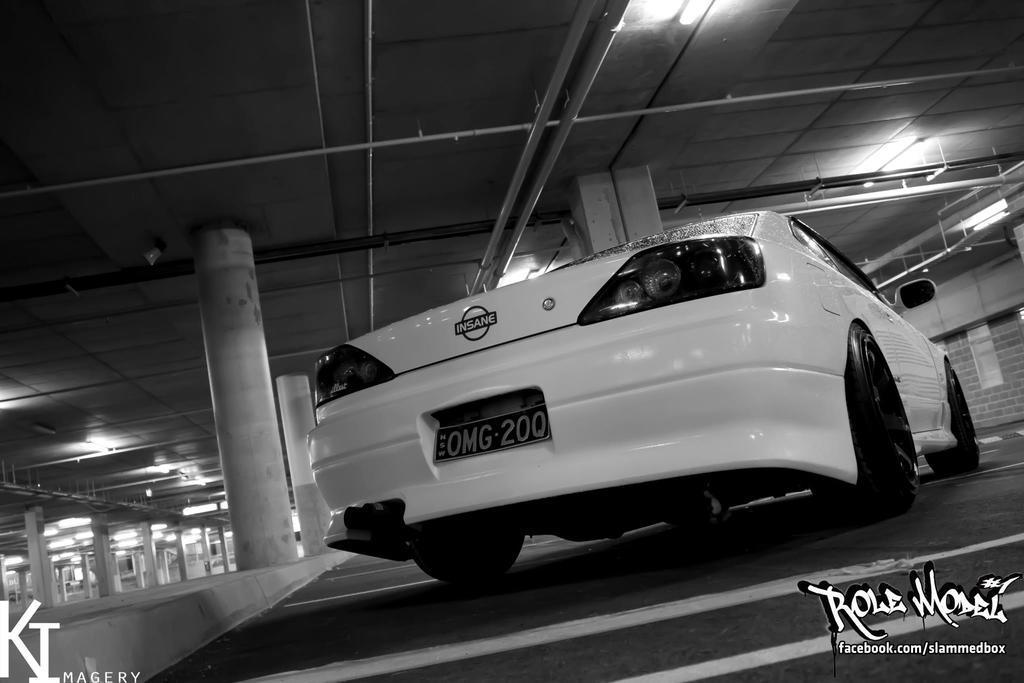Please provide a concise description of this image. In the foreground of this image, there is a car on the floor. In the background, there are pillars and lights to the ceiling. 